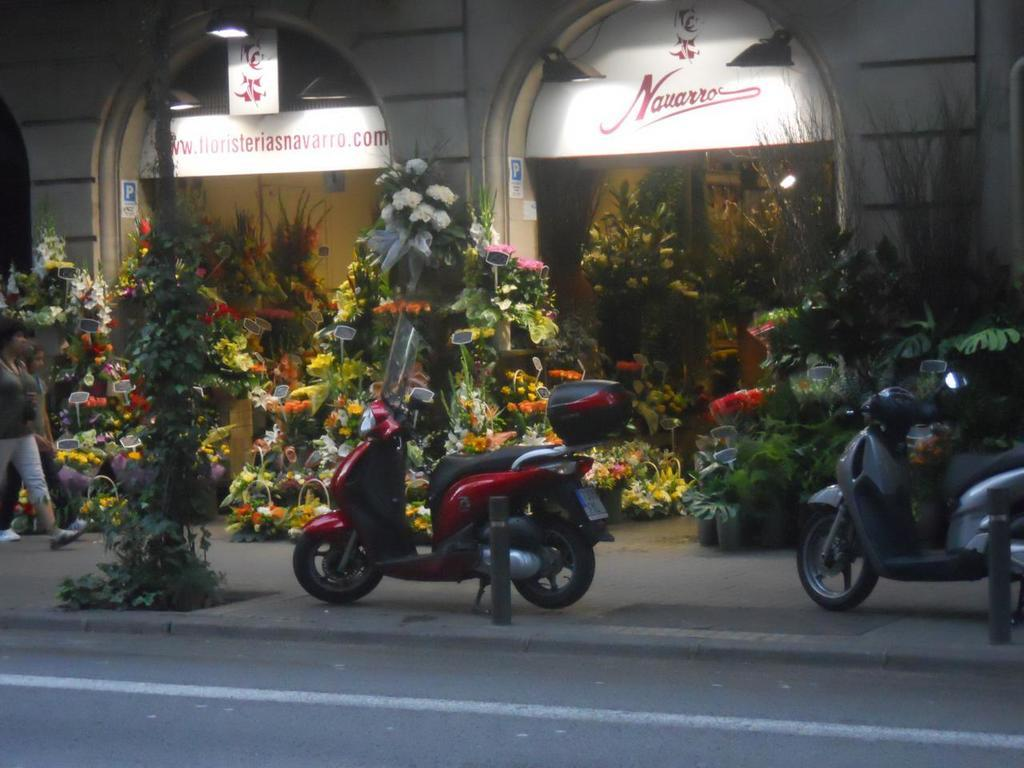What is at the bottom of the image? There is a road at the bottom of the image. What can be seen on the road? There are vehicles on the road. What is visible in the background of the image? There are flower bouquets in the background of the image. What is the lady in the image doing? The lady is walking to the left side of the image. What type of jelly can be seen on the vehicles in the image? There is no jelly present on the vehicles in the image. How many roses are visible in the image? There is no rose present in the image; only flower bouquets are mentioned. 